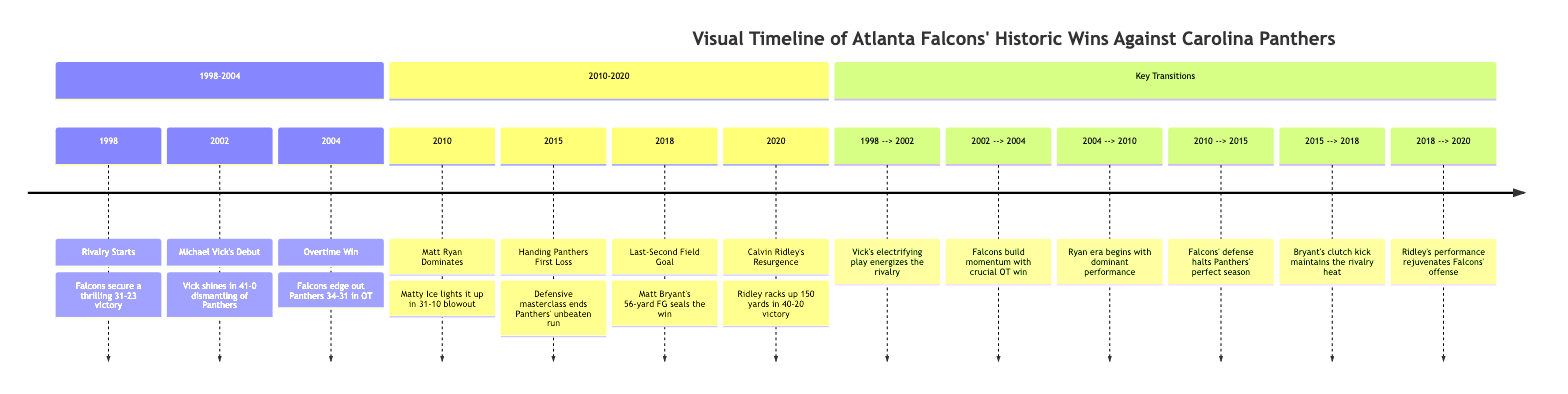What year did the Falcons secure a thrilling victory against the Panthers? The diagram indicates that the Falcons secured a thrilling 31-23 victory in 1998. This can be found under the first section, where this specific win is documented.
Answer: 1998 Who shone in the 2002 game that resulted in a 41-0 victory? In the 2002 match against the Panthers, Michael Vick is noted as the key player. The timeline specifies that it was his debut and highlights his significant contribution in that game.
Answer: Michael Vick How many overtime wins do the Falcons have against the Panthers before 2010? The diagram mentions only one overtime win against the Panthers, which took place in 2004. This is represented as a single event between 2002 and 2010 in the timeline.
Answer: 1 What pivotal event happened for the Falcons in 2015 regarding the Panthers' record? The diagram highlights that in 2015, the Falcons handed the Panthers their first loss of the season. This indicates a significant turning point for the Panthers' previously unbeaten season.
Answer: First Loss Which player’s kicking sealed the win in 2018? The diagram describes Matt Bryant's contribution in 2018, noting that he made a last-second field goal that sealed the victory for the Falcons. This specific play is made clear in the section concerning wins.
Answer: Matt Bryant How many key transitions are listed in the timeline? The timeline illustrates six key transitions that indicate shifts in rivalry dynamics. Each transition captures an essential moment that helped define the competition between the Falcons and Panthers.
Answer: 6 What was the score of the 2010 game between the Falcons and Panthers? The score of the 2010 game is explicitly mentioned in the timeline as a 31-10 blowout in favor of the Falcons, clearly noted with the year and context.
Answer: 31-10 Which player rejuvenated the Falcons' offense in 2020? The diagram indicates that Calvin Ridley played a crucial role in rejuvenating the Falcons' offense during the 2020 game, where he racked up 150 yards. This highlight shows his significant impact on the outcome.
Answer: Calvin Ridley 